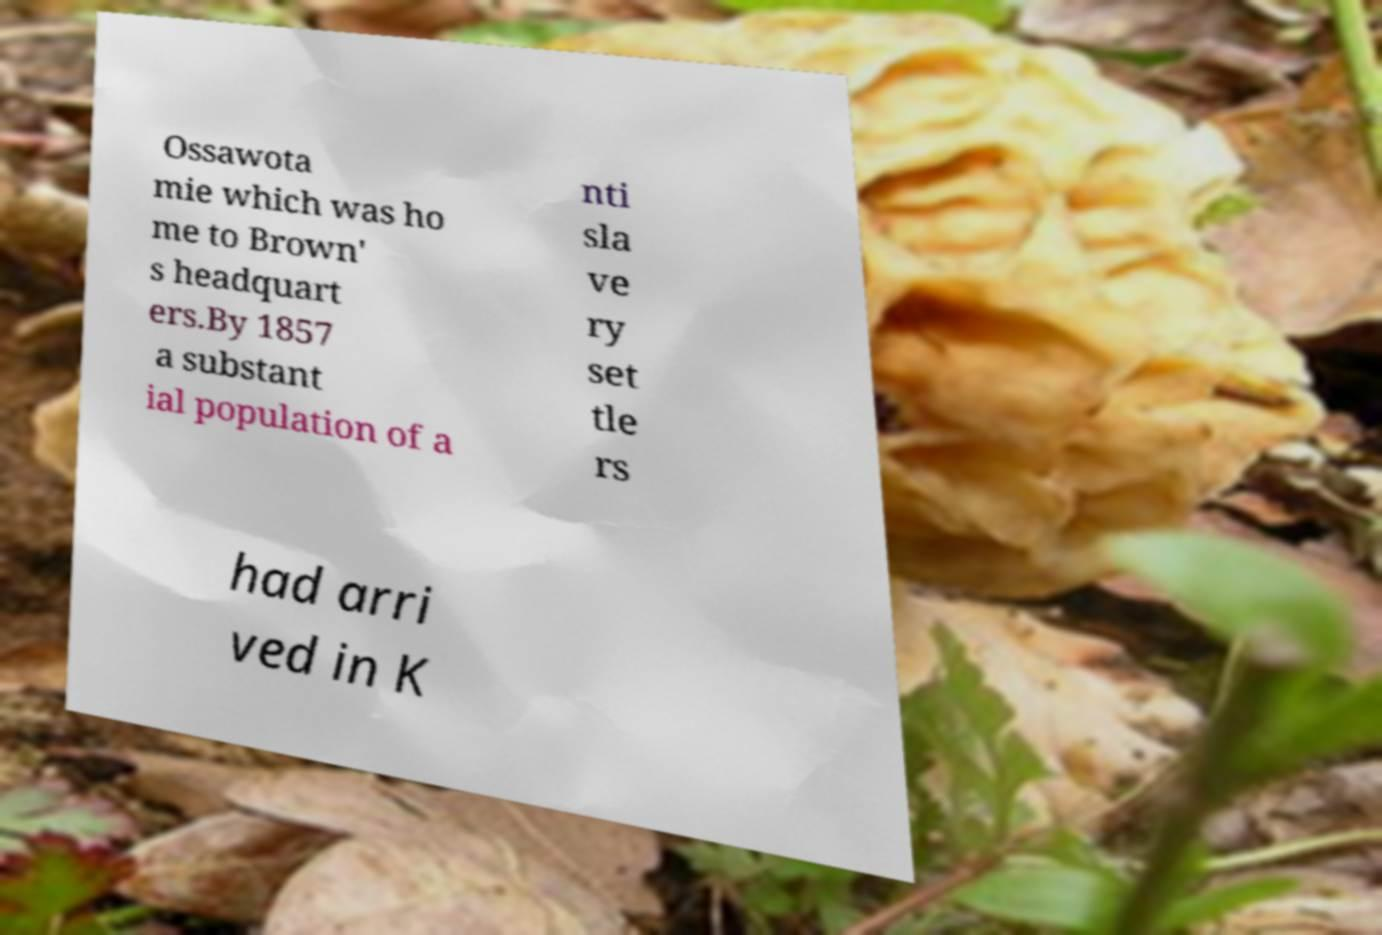Could you extract and type out the text from this image? Ossawota mie which was ho me to Brown' s headquart ers.By 1857 a substant ial population of a nti sla ve ry set tle rs had arri ved in K 